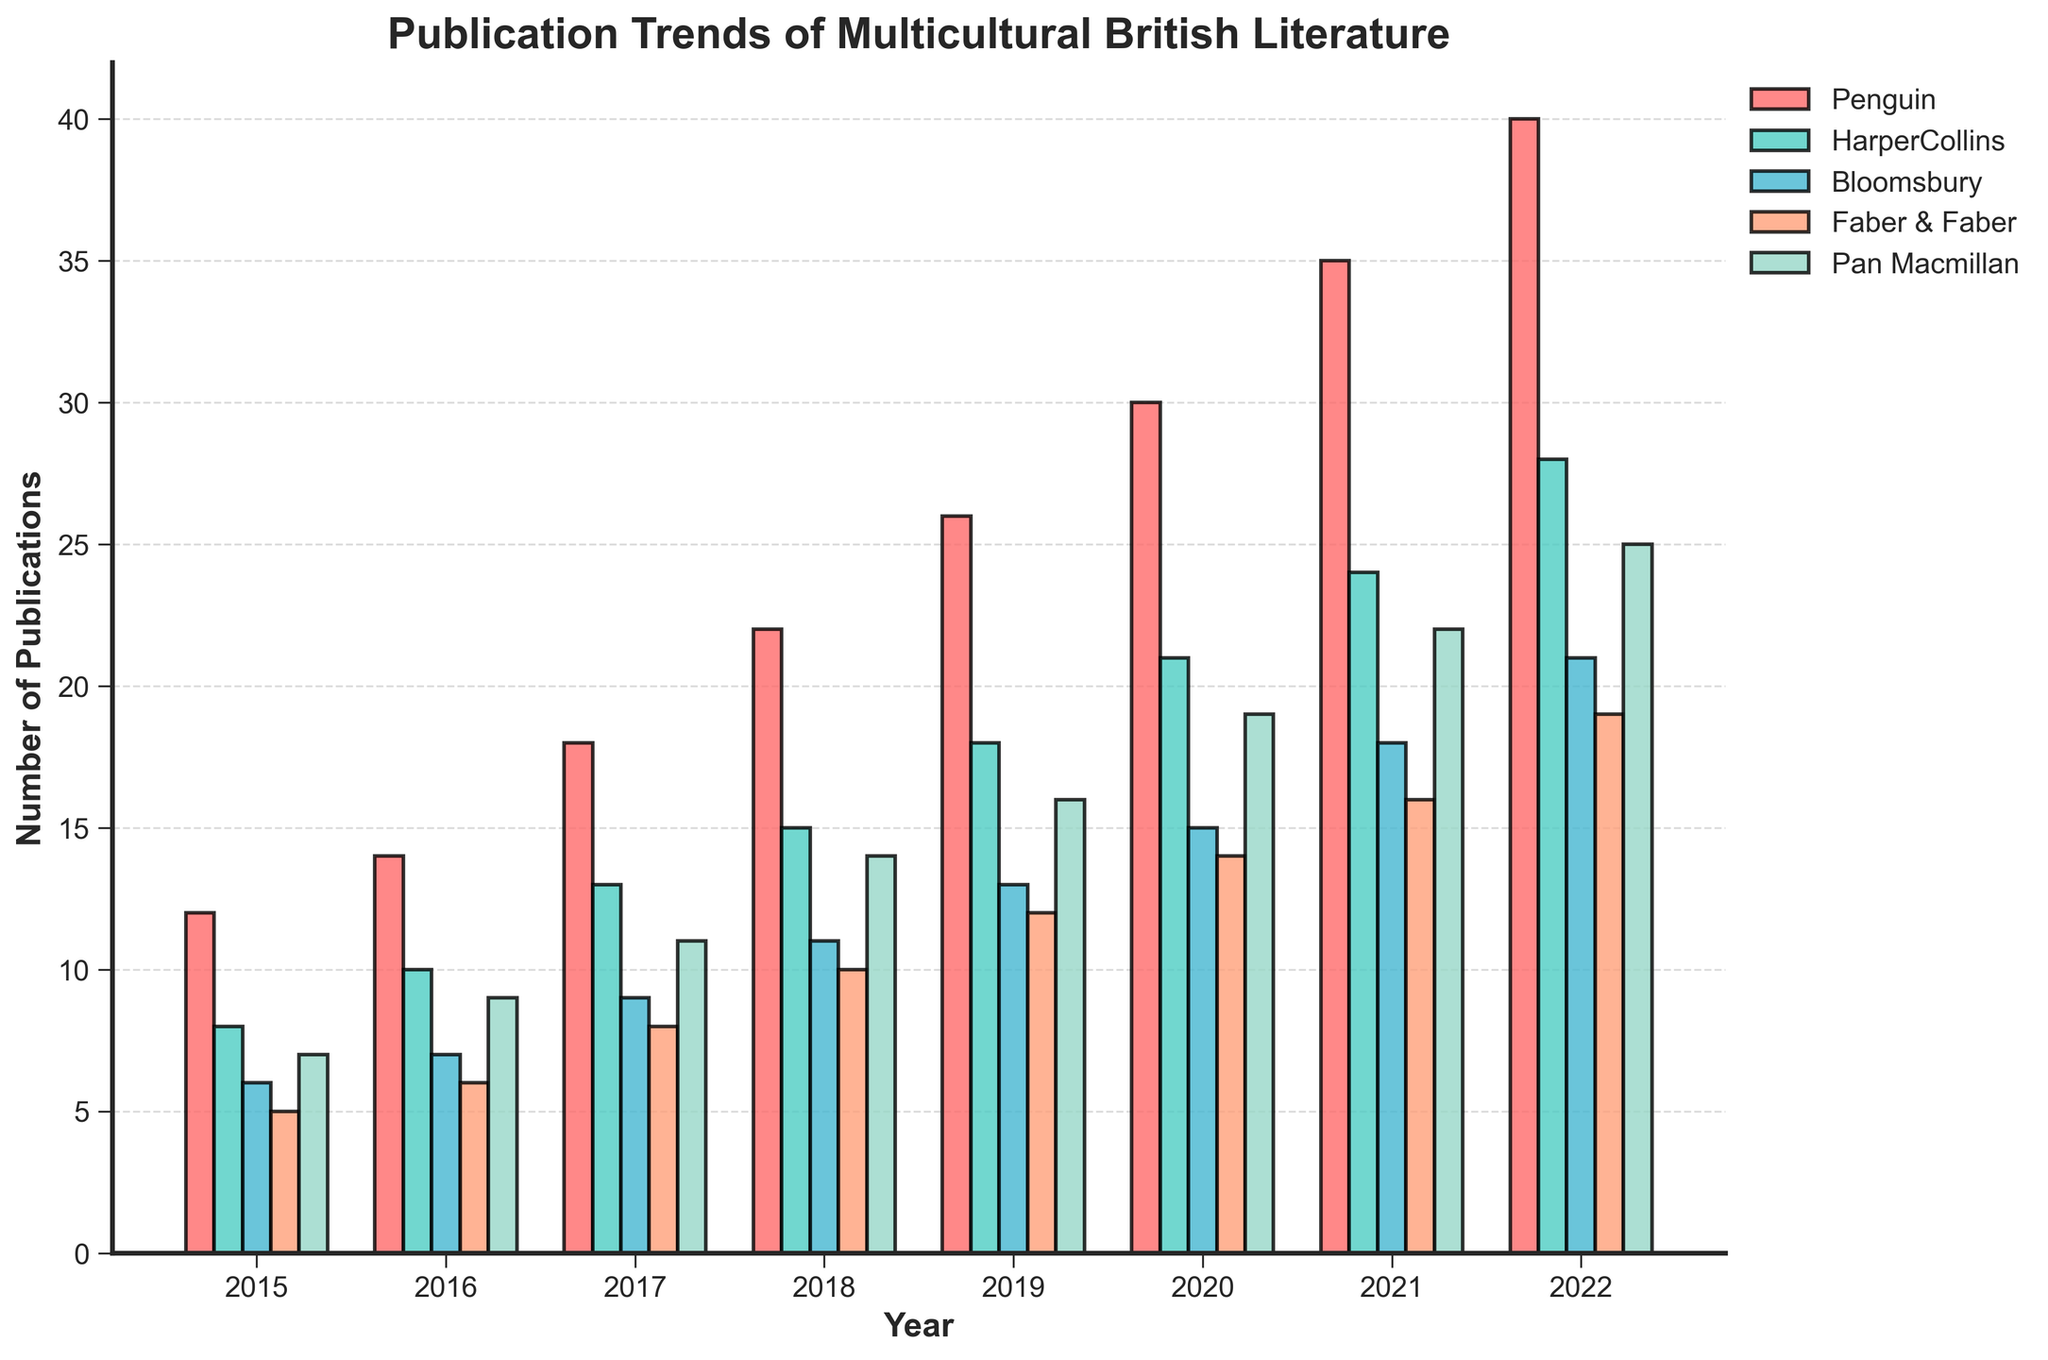Which publishing house had the highest number of publications in 2022? To determine the publishing house with the highest number of publications in 2022, observe the height of the bars for each publishing house in the year 2022. The tallest bar belongs to Penguin with 40 publications.
Answer: Penguin Between 2016 and 2018, which publishing house showed the greatest increase in the number of publications? Calculate the increase in the number of publications for each publisher by subtracting the number of publications in 2016 from the number in 2018. Penguin increased by (22 - 14) = 8, HarperCollins by (15 - 10) = 5, Bloomsbury by (11 - 7) = 4, Faber & Faber by (10 - 6) = 4, and Pan Macmillan by (14 - 9) = 5. Penguin showed the greatest increase.
Answer: Penguin What is the average number of publications by Faber & Faber over the years 2015-2022? Sum the total number of publications by Faber & Faber from 2015-2022 and divide by the number of years: (5 + 6 + 8 + 10 + 12 + 14 + 16 + 19) = 90. The average is 90 / 8 = 11.25.
Answer: 11.25 In which year did Bloomsbury publish an equal number of books as Pan Macmillan published in 2015? Pan Macmillan published 7 books in 2015. Check the bars representing Bloomsbury’s publications to find the year with 7 publications, which is 2016.
Answer: 2016 Which publishing house had the least growth in the number of publications between 2020 and 2021? Determine the growth for each publishing house by subtracting the number of publications in 2020 from the number in 2021: Penguin (35 - 30) = 5, HarperCollins (24 - 21) = 3, Bloomsbury (18 - 15) = 3, Faber & Faber (16 - 14) = 2, Pan Macmillan (22 - 19) = 3. Faber & Faber had the least growth with a difference of 2.
Answer: Faber & Faber Which years did HarperCollins publish fewer books than Bloomsbury? Compare the heights of the bars for HarperCollins and Bloomsbury in each year. HarperCollins published fewer books in 2015, 2016, and 2021.
Answer: 2015, 2016, 2021 In 2019, how many more books did Penguin publish compared to Faber & Faber? Determine the number of books published by Penguin and Faber & Faber in 2019 and find the difference: Penguin (26), Faber & Faber (12). The difference is 26 - 12 = 14 books.
Answer: 14 